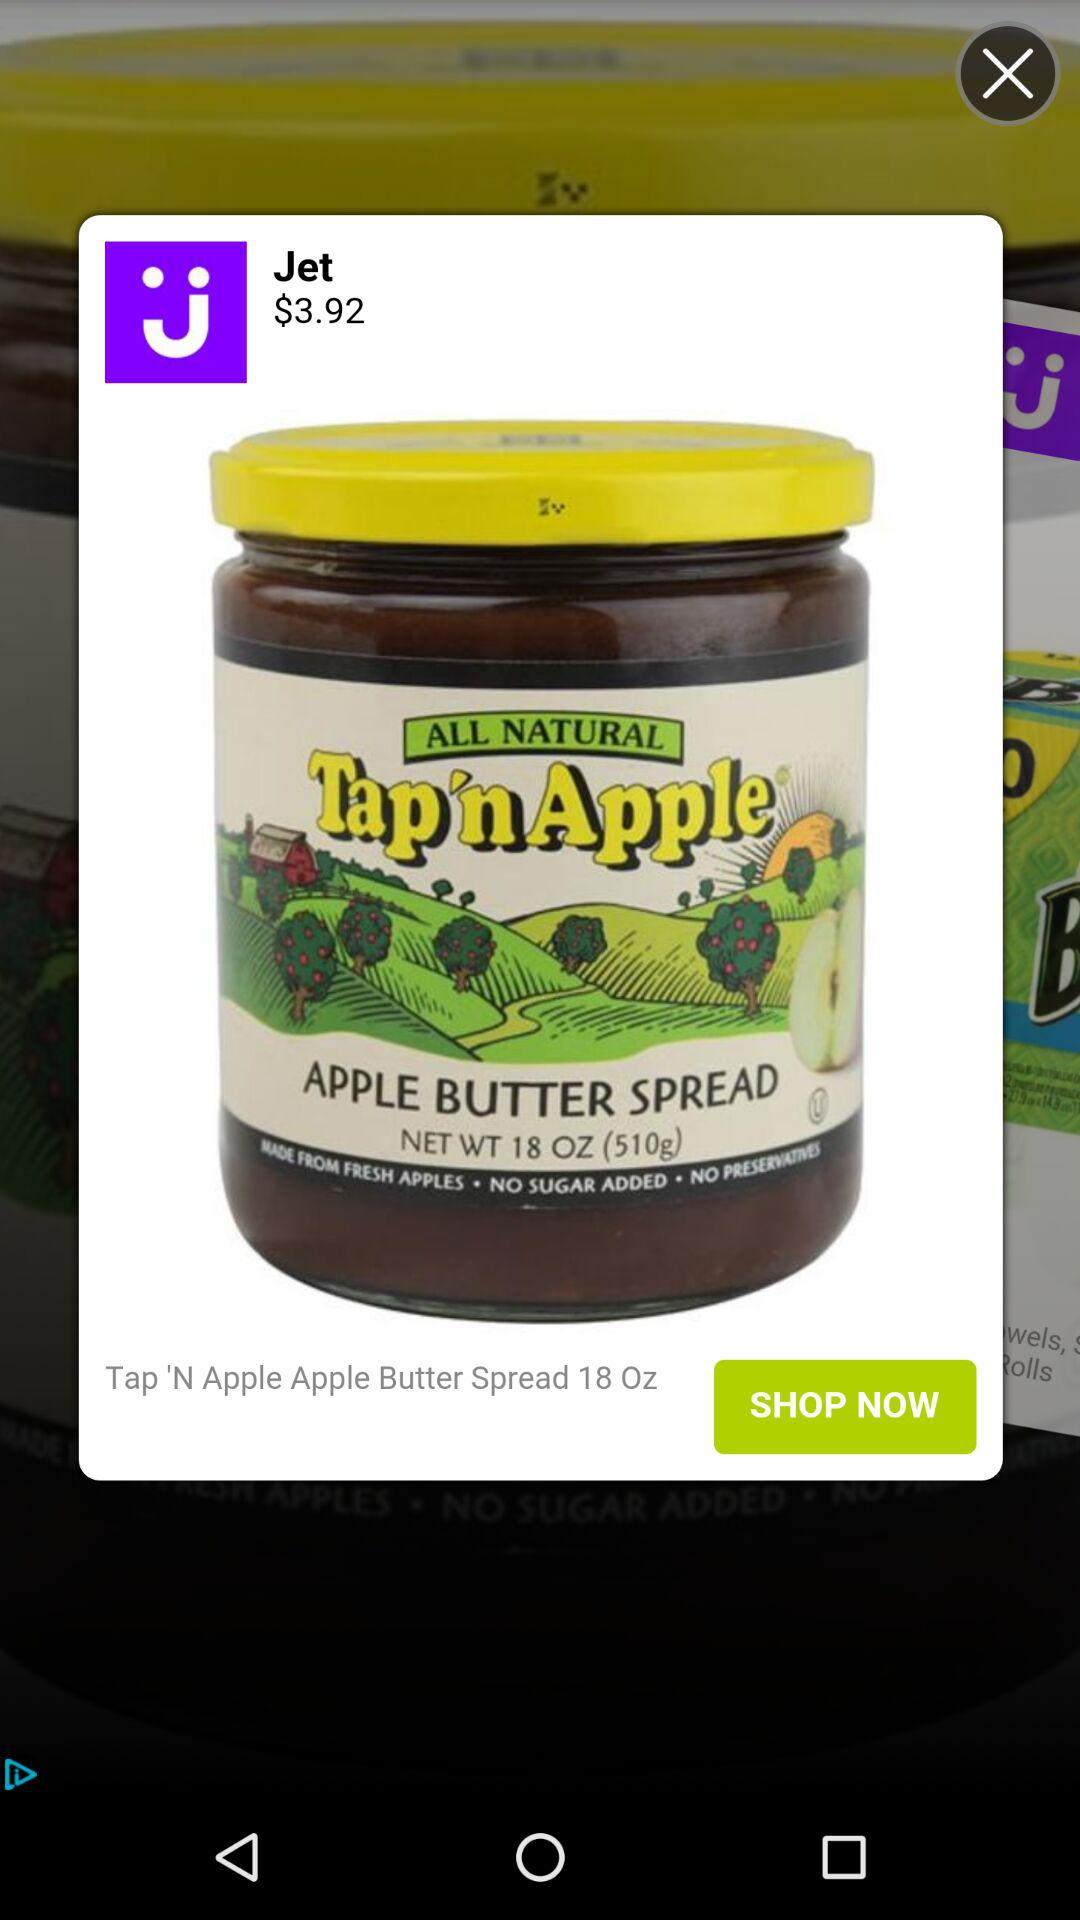What is the price of the item?
Answer the question using a single word or phrase. $3.92 